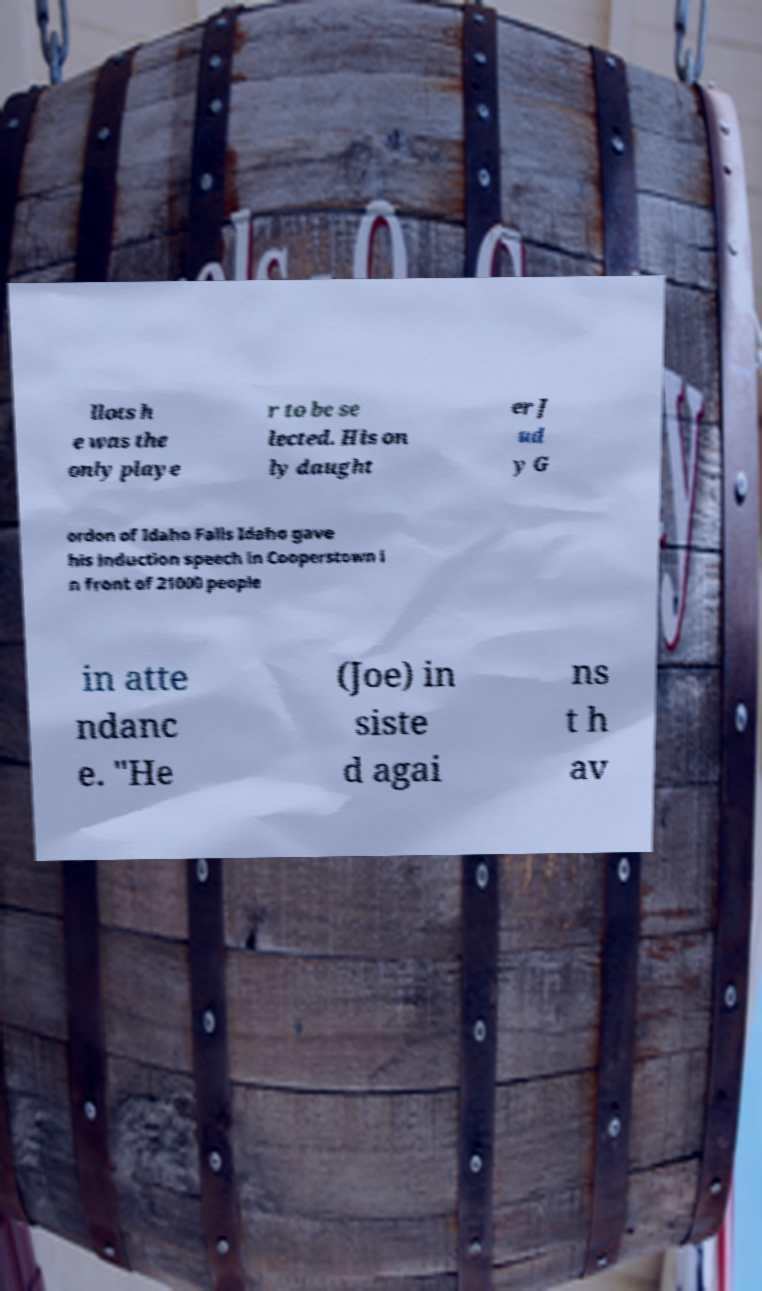Can you accurately transcribe the text from the provided image for me? llots h e was the only playe r to be se lected. His on ly daught er J ud y G ordon of Idaho Falls Idaho gave his induction speech in Cooperstown i n front of 21000 people in atte ndanc e. "He (Joe) in siste d agai ns t h av 